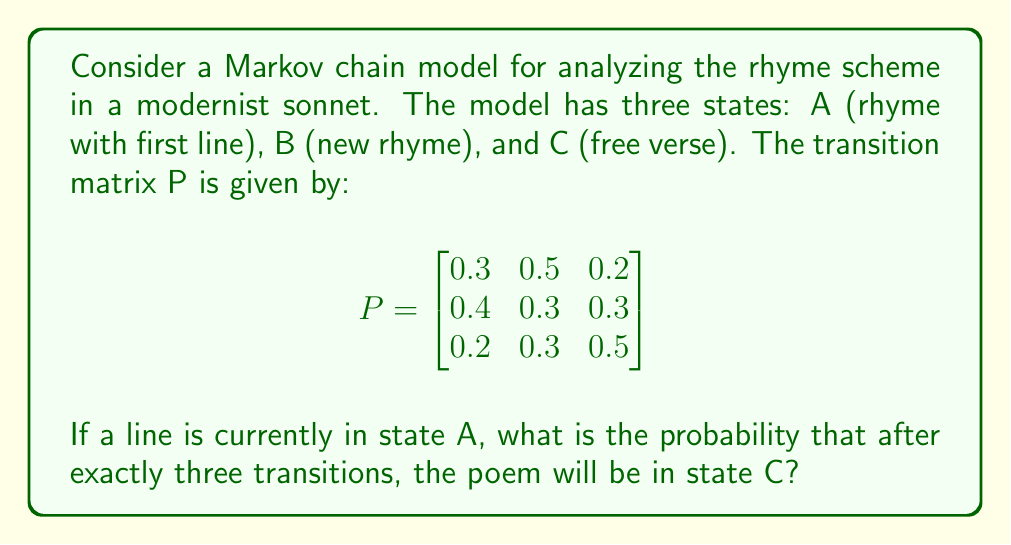Give your solution to this math problem. To solve this problem, we need to use the Chapman-Kolmogorov equations and calculate $P^3$. This will give us the probability of moving from any state to any other state in exactly three steps.

Step 1: Calculate $P^2$
$$P^2 = P \times P = \begin{bmatrix}
0.32 & 0.39 & 0.29 \\
0.31 & 0.37 & 0.32 \\
0.28 & 0.33 & 0.39
\end{bmatrix}$$

Step 2: Calculate $P^3$
$$P^3 = P^2 \times P = \begin{bmatrix}
0.307 & 0.363 & 0.330 \\
0.304 & 0.359 & 0.337 \\
0.298 & 0.351 & 0.351
\end{bmatrix}$$

Step 3: Interpret the result
The probability of moving from state A to state C in exactly three steps is given by the element in the first row, third column of $P^3$, which is 0.330.

Therefore, the probability that after exactly three transitions, the poem will be in state C, given that it started in state A, is 0.330 or 33.0%.
Answer: 0.330 